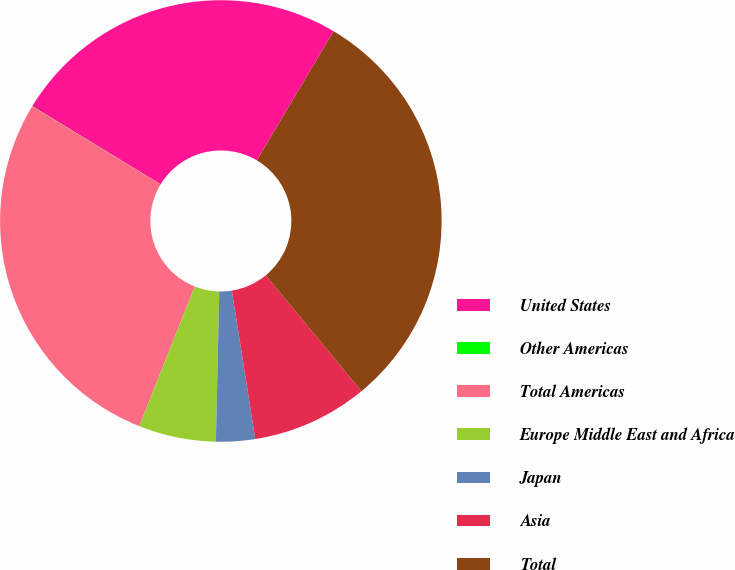Convert chart to OTSL. <chart><loc_0><loc_0><loc_500><loc_500><pie_chart><fcel>United States<fcel>Other Americas<fcel>Total Americas<fcel>Europe Middle East and Africa<fcel>Japan<fcel>Asia<fcel>Total<nl><fcel>24.83%<fcel>0.02%<fcel>27.66%<fcel>5.67%<fcel>2.85%<fcel>8.5%<fcel>30.48%<nl></chart> 